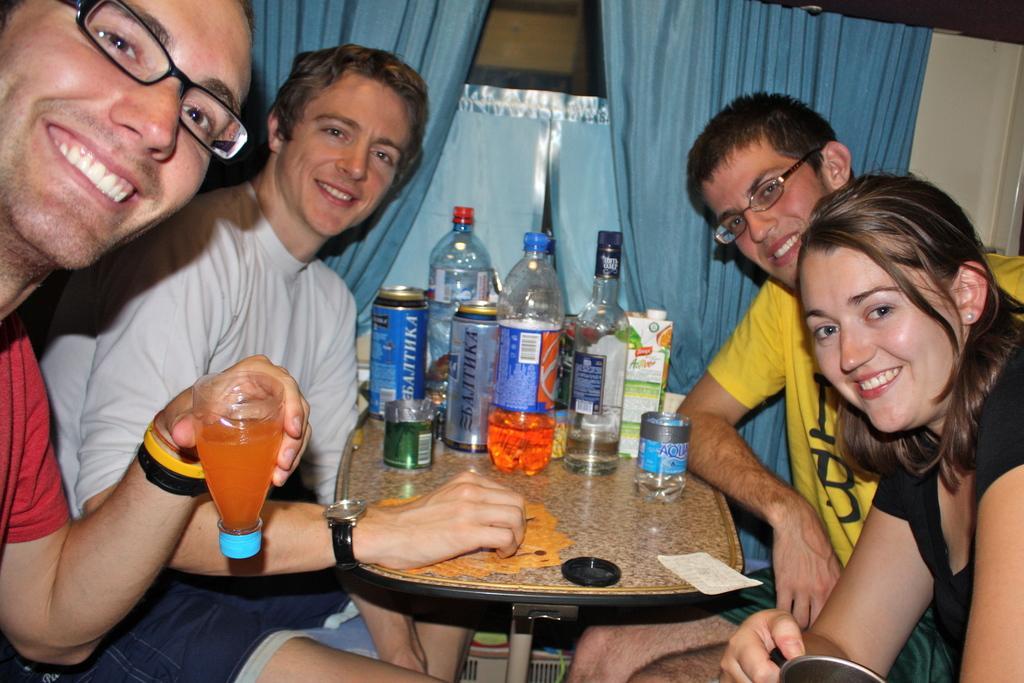Can you describe this image briefly? In this picture we can see three men and one woman sitting on chair and smiling and in front of them there is table and on table we can see bottles, boxes, tin, paper and here man holding glass in his hand and in background we can see curtains. 